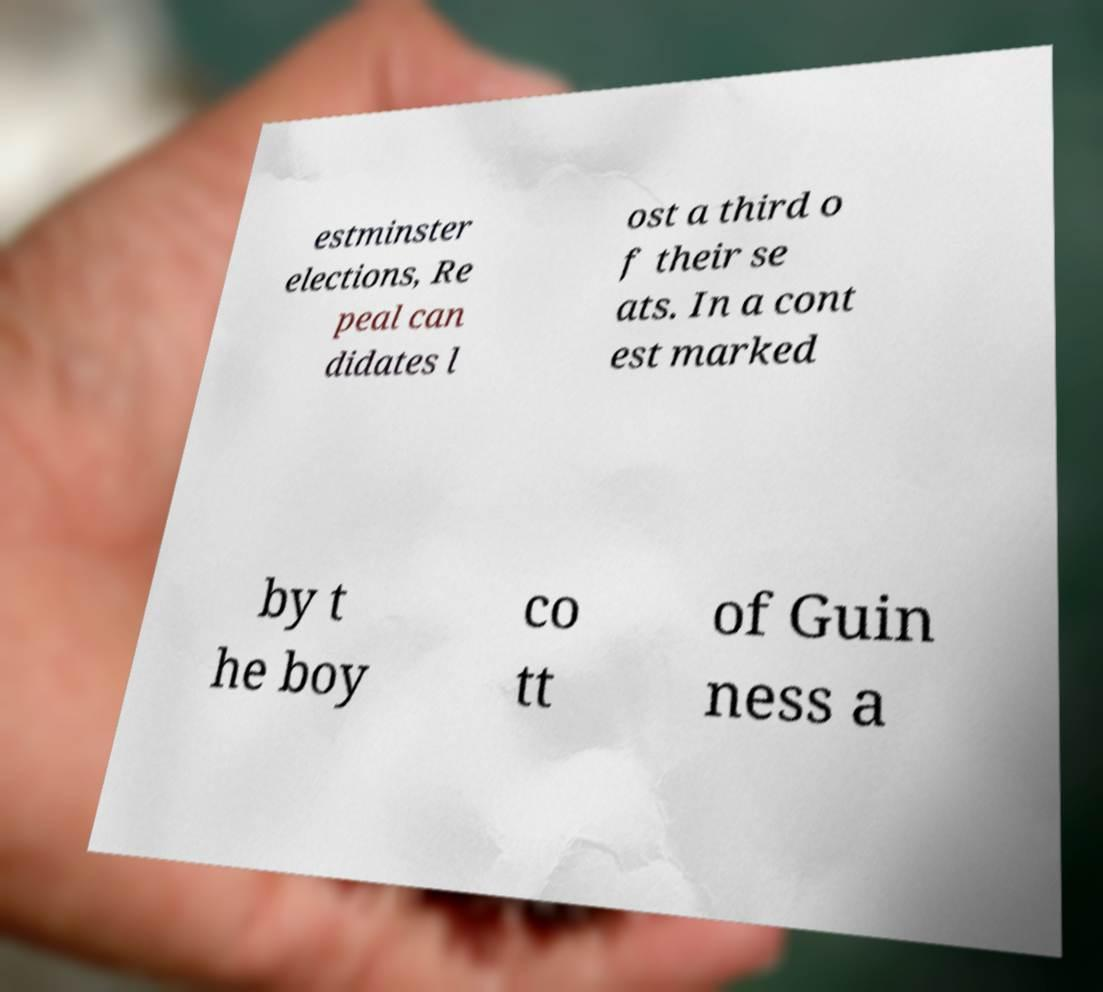For documentation purposes, I need the text within this image transcribed. Could you provide that? estminster elections, Re peal can didates l ost a third o f their se ats. In a cont est marked by t he boy co tt of Guin ness a 